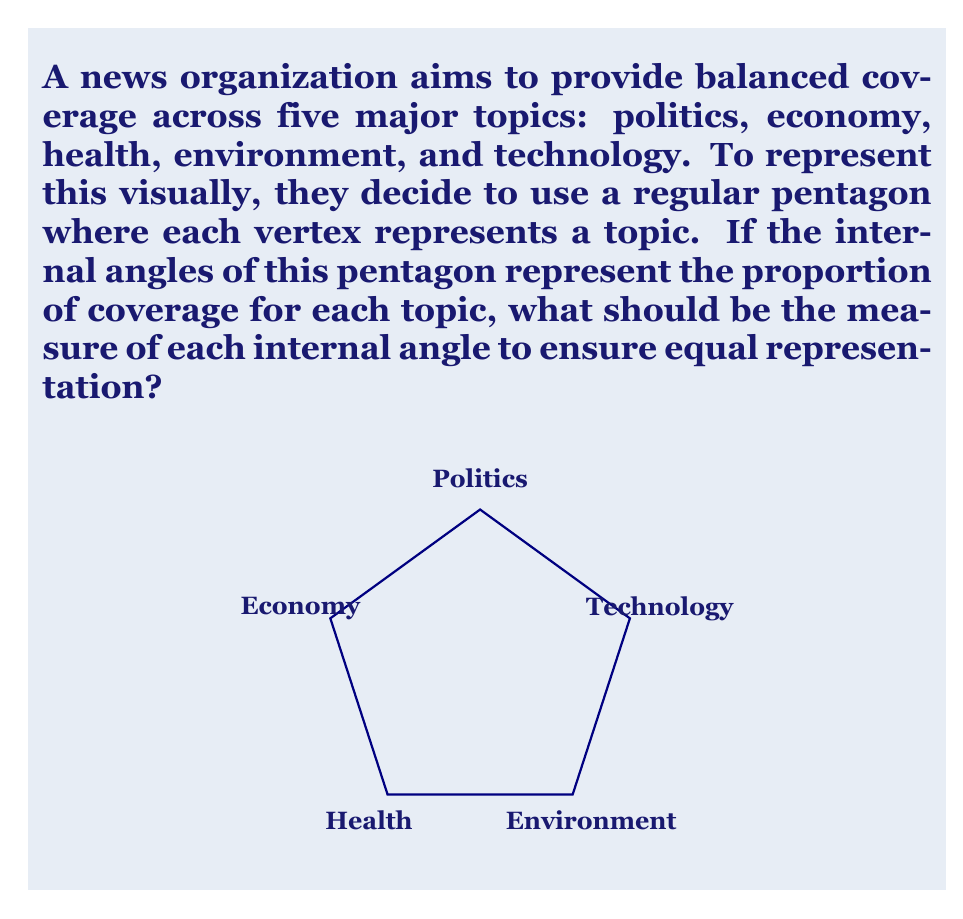Can you solve this math problem? To solve this problem, we need to follow these steps:

1) First, recall the formula for the sum of interior angles of a polygon:
   $$(n-2) \times 180°$$
   where $n$ is the number of sides.

2) For a pentagon, $n = 5$, so the sum of interior angles is:
   $$(5-2) \times 180° = 3 \times 180° = 540°$$

3) Since we want equal representation for each topic, we need to divide this total evenly among the five angles:

   $$\frac{540°}{5} = 108°$$

This result makes sense geometrically as well. In a regular pentagon, all interior angles are congruent, and we've just calculated that measure.

4) We can verify this result using the formula for the measure of each interior angle in a regular polygon:
   $$\frac{(n-2) \times 180°}{n}$$

   Plugging in $n = 5$:
   $$\frac{(5-2) \times 180°}{5} = \frac{540°}{5} = 108°$$

This confirms our calculation.
Answer: Each internal angle of the pentagon should measure $108°$ to ensure equal representation of the five news topics. 